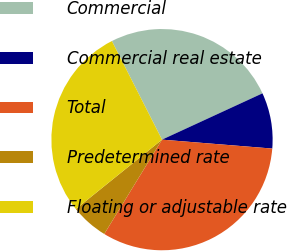<chart> <loc_0><loc_0><loc_500><loc_500><pie_chart><fcel>Commercial<fcel>Commercial real estate<fcel>Total<fcel>Predetermined rate<fcel>Floating or adjustable rate<nl><fcel>25.61%<fcel>8.16%<fcel>32.46%<fcel>5.46%<fcel>28.31%<nl></chart> 